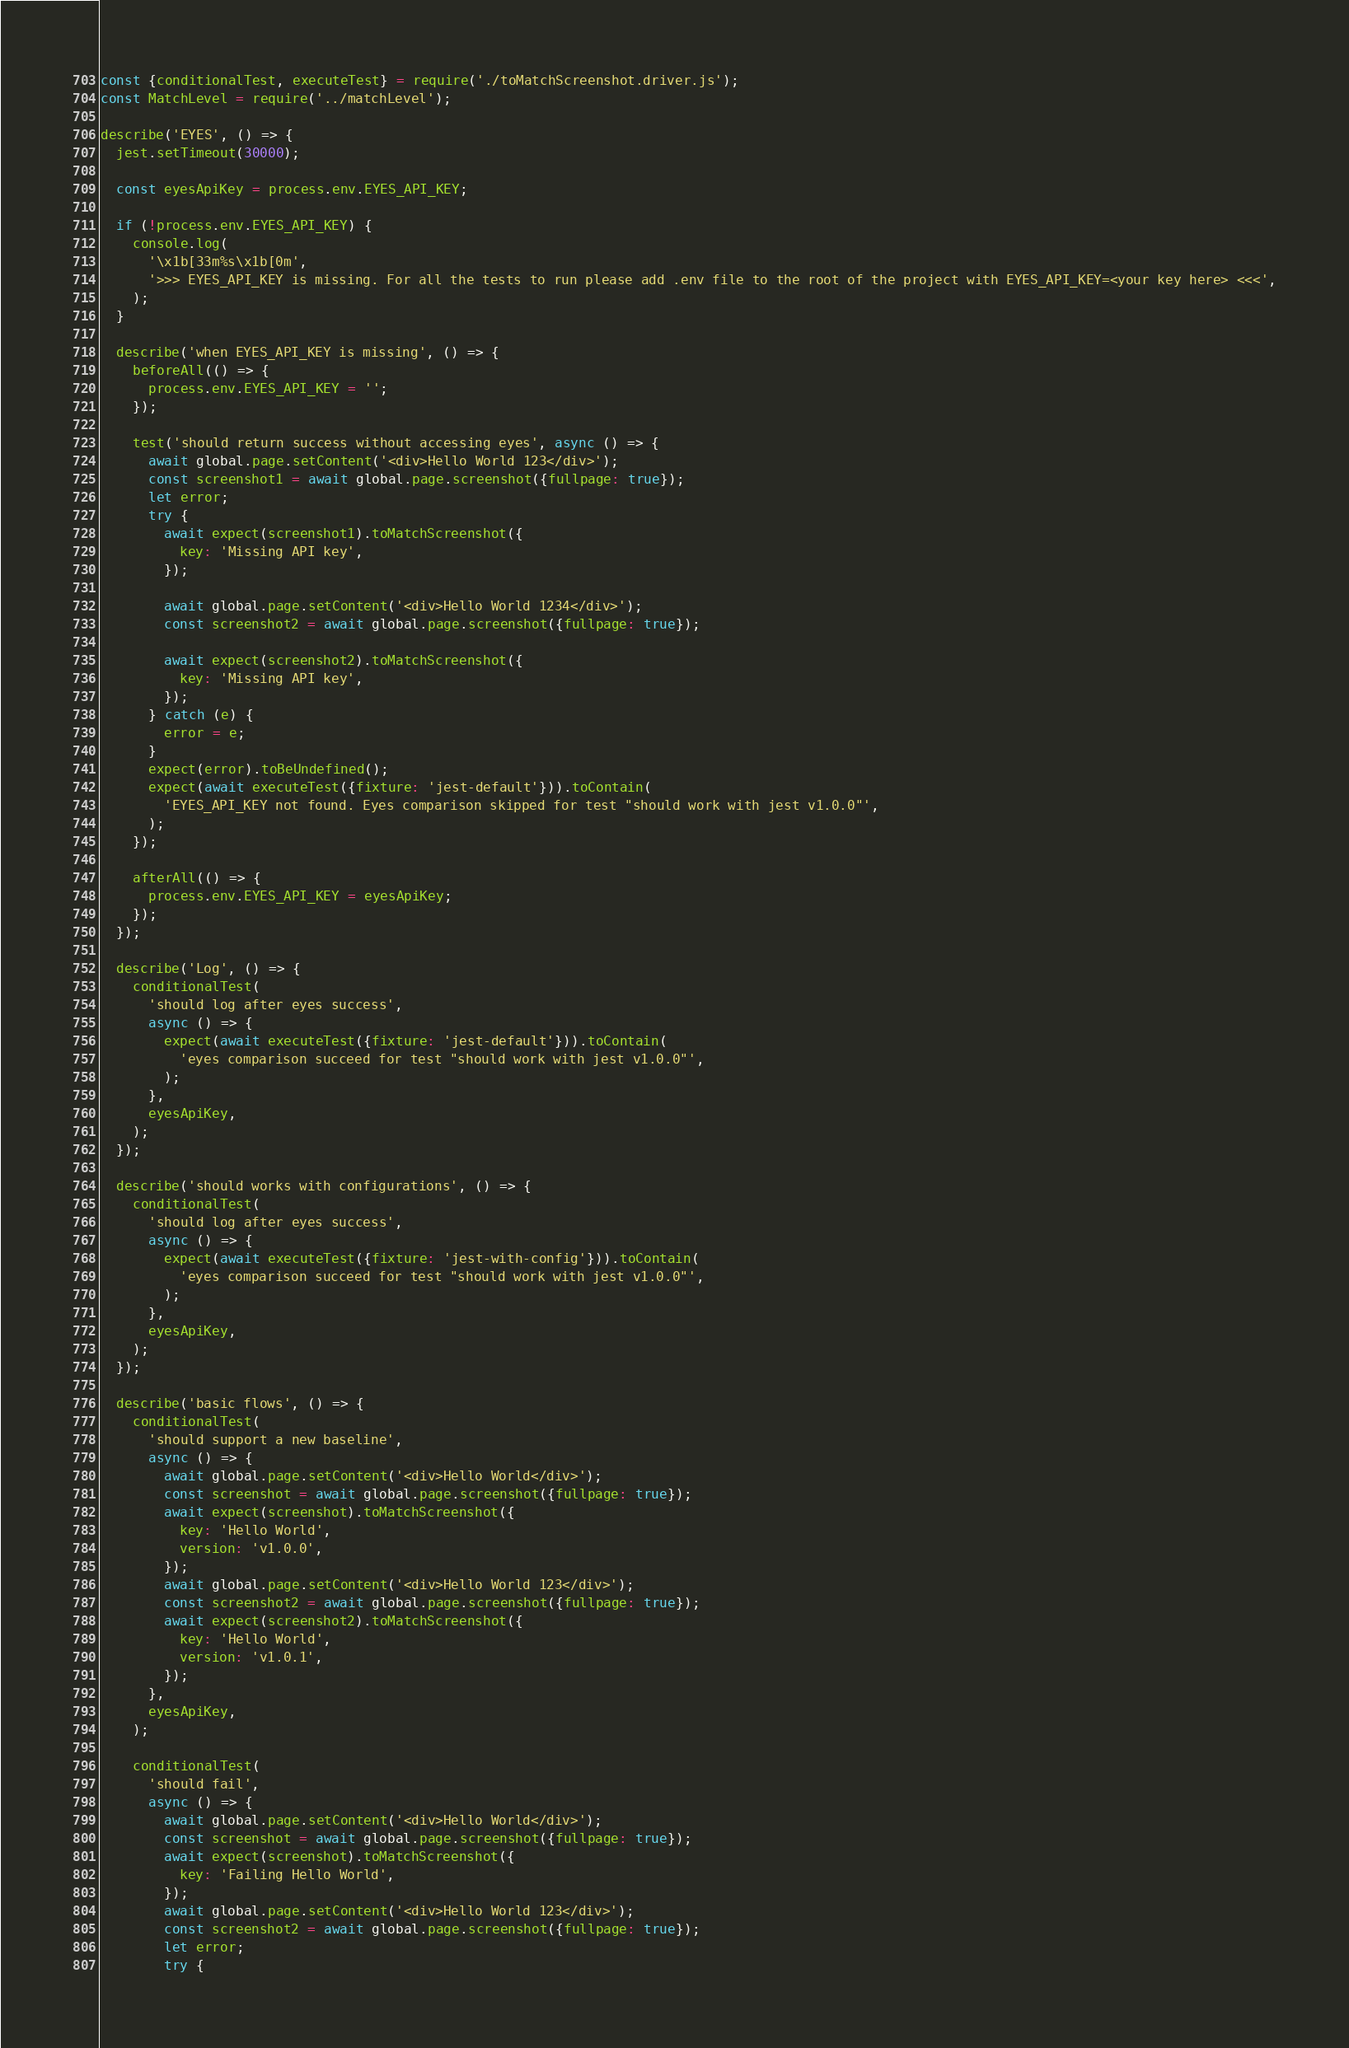<code> <loc_0><loc_0><loc_500><loc_500><_JavaScript_>const {conditionalTest, executeTest} = require('./toMatchScreenshot.driver.js');
const MatchLevel = require('../matchLevel');

describe('EYES', () => {
  jest.setTimeout(30000);

  const eyesApiKey = process.env.EYES_API_KEY;

  if (!process.env.EYES_API_KEY) {
    console.log(
      '\x1b[33m%s\x1b[0m',
      '>>> EYES_API_KEY is missing. For all the tests to run please add .env file to the root of the project with EYES_API_KEY=<your key here> <<<',
    );
  }

  describe('when EYES_API_KEY is missing', () => {
    beforeAll(() => {
      process.env.EYES_API_KEY = '';
    });

    test('should return success without accessing eyes', async () => {
      await global.page.setContent('<div>Hello World 123</div>');
      const screenshot1 = await global.page.screenshot({fullpage: true});
      let error;
      try {
        await expect(screenshot1).toMatchScreenshot({
          key: 'Missing API key',
        });

        await global.page.setContent('<div>Hello World 1234</div>');
        const screenshot2 = await global.page.screenshot({fullpage: true});

        await expect(screenshot2).toMatchScreenshot({
          key: 'Missing API key',
        });
      } catch (e) {
        error = e;
      }
      expect(error).toBeUndefined();
      expect(await executeTest({fixture: 'jest-default'})).toContain(
        'EYES_API_KEY not found. Eyes comparison skipped for test "should work with jest v1.0.0"',
      );
    });

    afterAll(() => {
      process.env.EYES_API_KEY = eyesApiKey;
    });
  });

  describe('Log', () => {
    conditionalTest(
      'should log after eyes success',
      async () => {
        expect(await executeTest({fixture: 'jest-default'})).toContain(
          'eyes comparison succeed for test "should work with jest v1.0.0"',
        );
      },
      eyesApiKey,
    );
  });

  describe('should works with configurations', () => {
    conditionalTest(
      'should log after eyes success',
      async () => {
        expect(await executeTest({fixture: 'jest-with-config'})).toContain(
          'eyes comparison succeed for test "should work with jest v1.0.0"',
        );
      },
      eyesApiKey,
    );
  });

  describe('basic flows', () => {
    conditionalTest(
      'should support a new baseline',
      async () => {
        await global.page.setContent('<div>Hello World</div>');
        const screenshot = await global.page.screenshot({fullpage: true});
        await expect(screenshot).toMatchScreenshot({
          key: 'Hello World',
          version: 'v1.0.0',
        });
        await global.page.setContent('<div>Hello World 123</div>');
        const screenshot2 = await global.page.screenshot({fullpage: true});
        await expect(screenshot2).toMatchScreenshot({
          key: 'Hello World',
          version: 'v1.0.1',
        });
      },
      eyesApiKey,
    );

    conditionalTest(
      'should fail',
      async () => {
        await global.page.setContent('<div>Hello World</div>');
        const screenshot = await global.page.screenshot({fullpage: true});
        await expect(screenshot).toMatchScreenshot({
          key: 'Failing Hello World',
        });
        await global.page.setContent('<div>Hello World 123</div>');
        const screenshot2 = await global.page.screenshot({fullpage: true});
        let error;
        try {</code> 